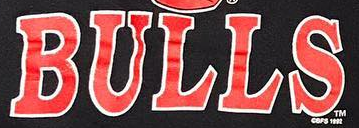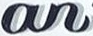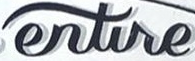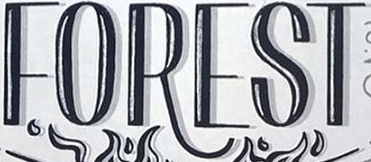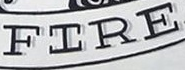What text is displayed in these images sequentially, separated by a semicolon? BULLS; an; entire; FOREST; FIRE 